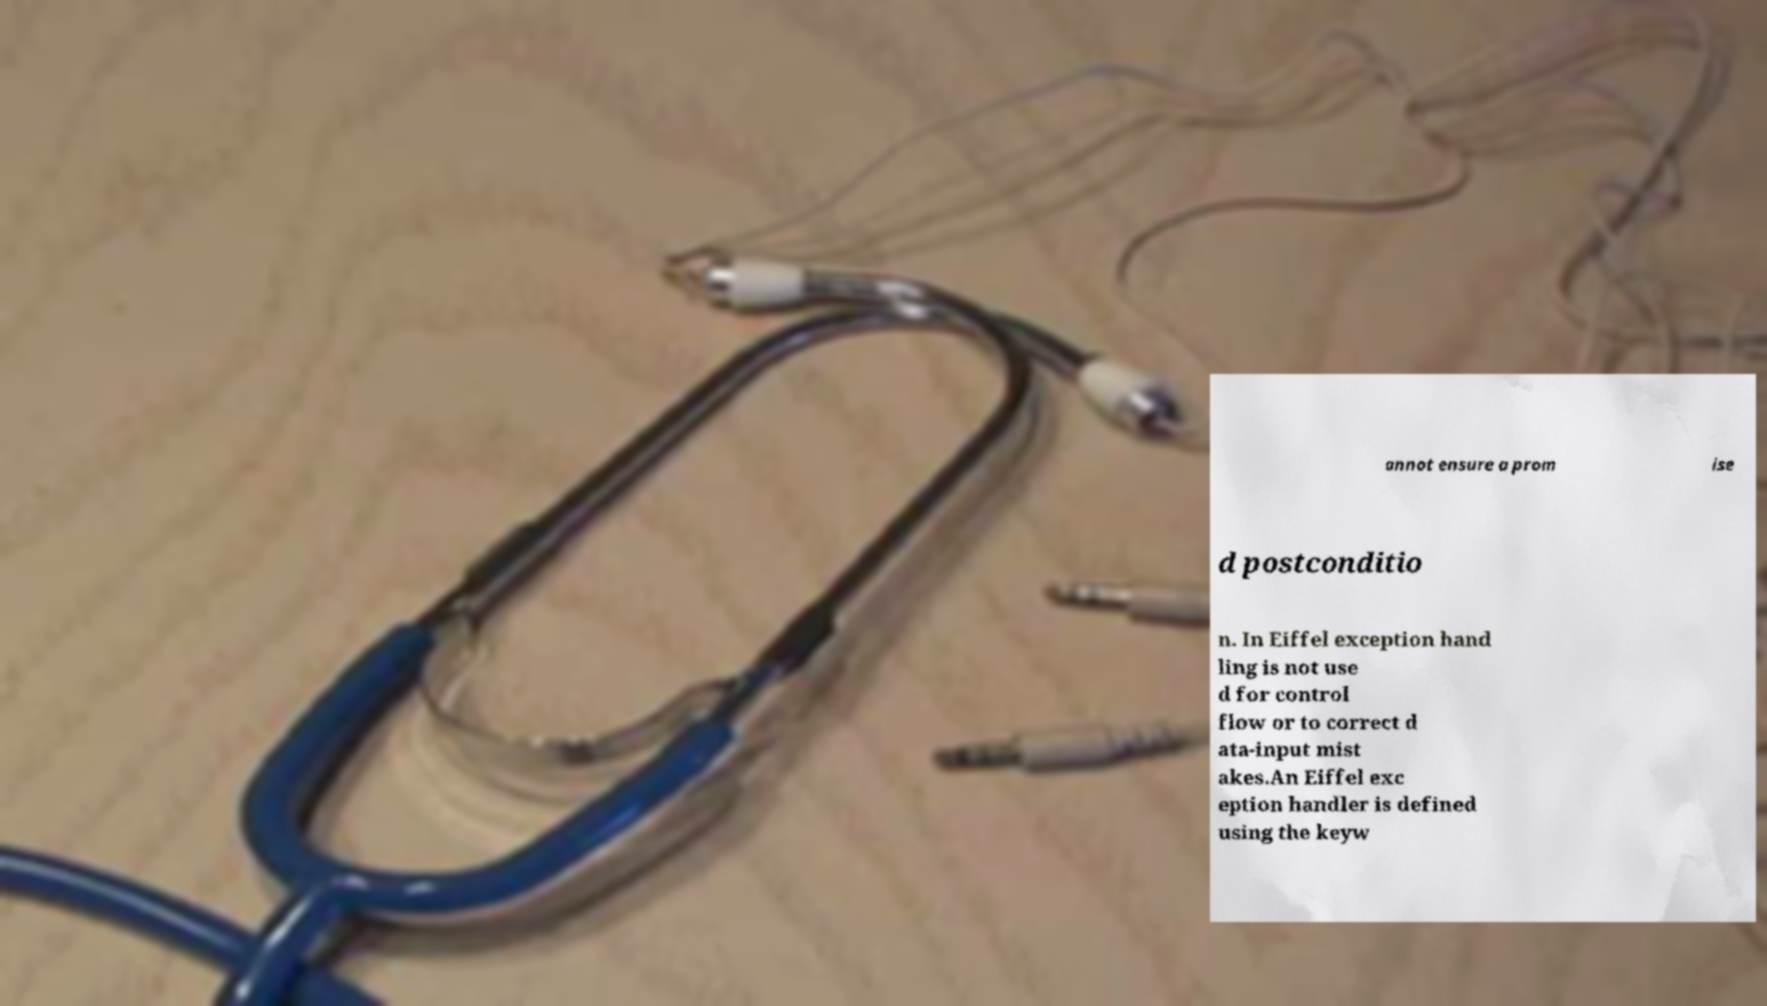For documentation purposes, I need the text within this image transcribed. Could you provide that? annot ensure a prom ise d postconditio n. In Eiffel exception hand ling is not use d for control flow or to correct d ata-input mist akes.An Eiffel exc eption handler is defined using the keyw 